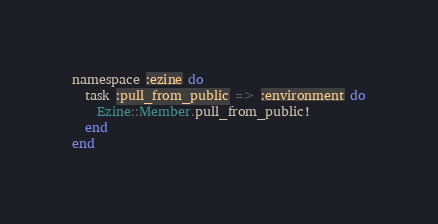<code> <loc_0><loc_0><loc_500><loc_500><_Ruby_>namespace :ezine do
  task :pull_from_public => :environment do
    Ezine::Member.pull_from_public!
  end
end
</code> 